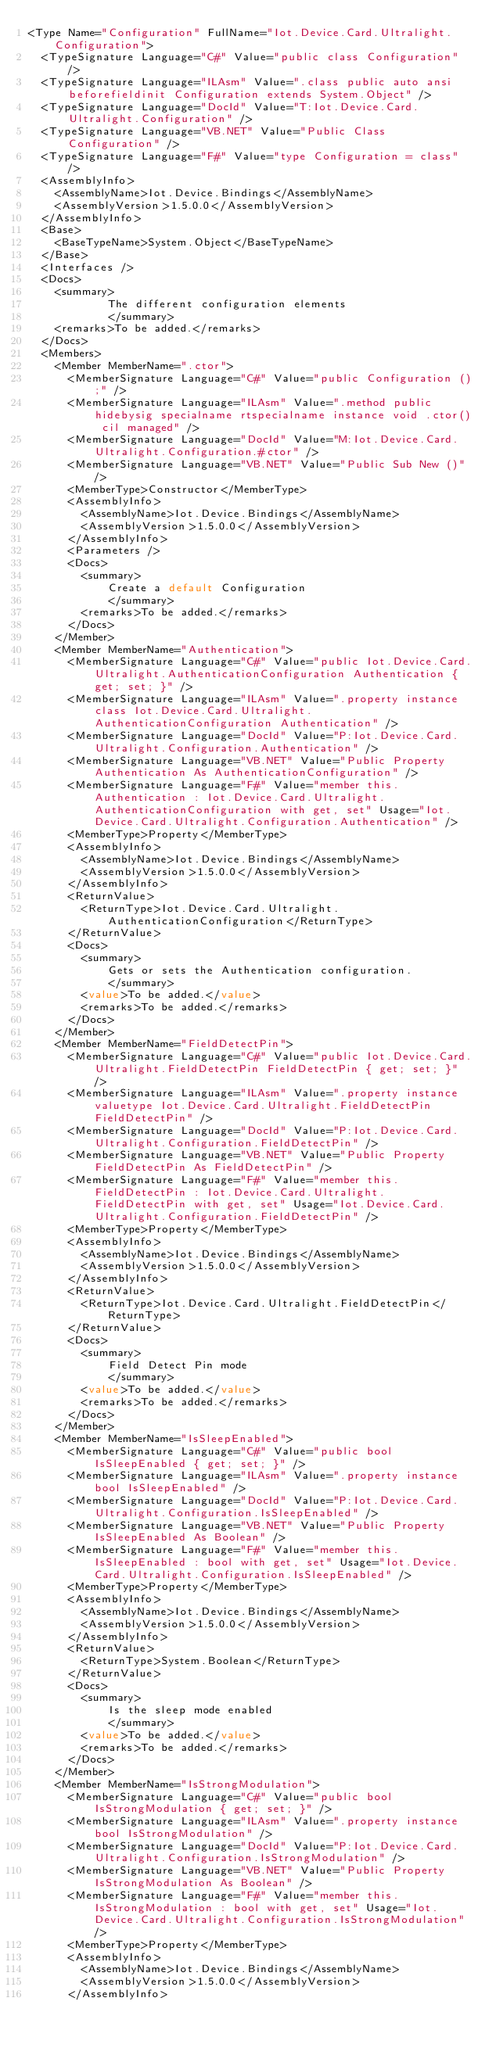Convert code to text. <code><loc_0><loc_0><loc_500><loc_500><_XML_><Type Name="Configuration" FullName="Iot.Device.Card.Ultralight.Configuration">
  <TypeSignature Language="C#" Value="public class Configuration" />
  <TypeSignature Language="ILAsm" Value=".class public auto ansi beforefieldinit Configuration extends System.Object" />
  <TypeSignature Language="DocId" Value="T:Iot.Device.Card.Ultralight.Configuration" />
  <TypeSignature Language="VB.NET" Value="Public Class Configuration" />
  <TypeSignature Language="F#" Value="type Configuration = class" />
  <AssemblyInfo>
    <AssemblyName>Iot.Device.Bindings</AssemblyName>
    <AssemblyVersion>1.5.0.0</AssemblyVersion>
  </AssemblyInfo>
  <Base>
    <BaseTypeName>System.Object</BaseTypeName>
  </Base>
  <Interfaces />
  <Docs>
    <summary>
            The different configuration elements
            </summary>
    <remarks>To be added.</remarks>
  </Docs>
  <Members>
    <Member MemberName=".ctor">
      <MemberSignature Language="C#" Value="public Configuration ();" />
      <MemberSignature Language="ILAsm" Value=".method public hidebysig specialname rtspecialname instance void .ctor() cil managed" />
      <MemberSignature Language="DocId" Value="M:Iot.Device.Card.Ultralight.Configuration.#ctor" />
      <MemberSignature Language="VB.NET" Value="Public Sub New ()" />
      <MemberType>Constructor</MemberType>
      <AssemblyInfo>
        <AssemblyName>Iot.Device.Bindings</AssemblyName>
        <AssemblyVersion>1.5.0.0</AssemblyVersion>
      </AssemblyInfo>
      <Parameters />
      <Docs>
        <summary>
            Create a default Configuration
            </summary>
        <remarks>To be added.</remarks>
      </Docs>
    </Member>
    <Member MemberName="Authentication">
      <MemberSignature Language="C#" Value="public Iot.Device.Card.Ultralight.AuthenticationConfiguration Authentication { get; set; }" />
      <MemberSignature Language="ILAsm" Value=".property instance class Iot.Device.Card.Ultralight.AuthenticationConfiguration Authentication" />
      <MemberSignature Language="DocId" Value="P:Iot.Device.Card.Ultralight.Configuration.Authentication" />
      <MemberSignature Language="VB.NET" Value="Public Property Authentication As AuthenticationConfiguration" />
      <MemberSignature Language="F#" Value="member this.Authentication : Iot.Device.Card.Ultralight.AuthenticationConfiguration with get, set" Usage="Iot.Device.Card.Ultralight.Configuration.Authentication" />
      <MemberType>Property</MemberType>
      <AssemblyInfo>
        <AssemblyName>Iot.Device.Bindings</AssemblyName>
        <AssemblyVersion>1.5.0.0</AssemblyVersion>
      </AssemblyInfo>
      <ReturnValue>
        <ReturnType>Iot.Device.Card.Ultralight.AuthenticationConfiguration</ReturnType>
      </ReturnValue>
      <Docs>
        <summary>
            Gets or sets the Authentication configuration.
            </summary>
        <value>To be added.</value>
        <remarks>To be added.</remarks>
      </Docs>
    </Member>
    <Member MemberName="FieldDetectPin">
      <MemberSignature Language="C#" Value="public Iot.Device.Card.Ultralight.FieldDetectPin FieldDetectPin { get; set; }" />
      <MemberSignature Language="ILAsm" Value=".property instance valuetype Iot.Device.Card.Ultralight.FieldDetectPin FieldDetectPin" />
      <MemberSignature Language="DocId" Value="P:Iot.Device.Card.Ultralight.Configuration.FieldDetectPin" />
      <MemberSignature Language="VB.NET" Value="Public Property FieldDetectPin As FieldDetectPin" />
      <MemberSignature Language="F#" Value="member this.FieldDetectPin : Iot.Device.Card.Ultralight.FieldDetectPin with get, set" Usage="Iot.Device.Card.Ultralight.Configuration.FieldDetectPin" />
      <MemberType>Property</MemberType>
      <AssemblyInfo>
        <AssemblyName>Iot.Device.Bindings</AssemblyName>
        <AssemblyVersion>1.5.0.0</AssemblyVersion>
      </AssemblyInfo>
      <ReturnValue>
        <ReturnType>Iot.Device.Card.Ultralight.FieldDetectPin</ReturnType>
      </ReturnValue>
      <Docs>
        <summary>
            Field Detect Pin mode
            </summary>
        <value>To be added.</value>
        <remarks>To be added.</remarks>
      </Docs>
    </Member>
    <Member MemberName="IsSleepEnabled">
      <MemberSignature Language="C#" Value="public bool IsSleepEnabled { get; set; }" />
      <MemberSignature Language="ILAsm" Value=".property instance bool IsSleepEnabled" />
      <MemberSignature Language="DocId" Value="P:Iot.Device.Card.Ultralight.Configuration.IsSleepEnabled" />
      <MemberSignature Language="VB.NET" Value="Public Property IsSleepEnabled As Boolean" />
      <MemberSignature Language="F#" Value="member this.IsSleepEnabled : bool with get, set" Usage="Iot.Device.Card.Ultralight.Configuration.IsSleepEnabled" />
      <MemberType>Property</MemberType>
      <AssemblyInfo>
        <AssemblyName>Iot.Device.Bindings</AssemblyName>
        <AssemblyVersion>1.5.0.0</AssemblyVersion>
      </AssemblyInfo>
      <ReturnValue>
        <ReturnType>System.Boolean</ReturnType>
      </ReturnValue>
      <Docs>
        <summary>
            Is the sleep mode enabled
            </summary>
        <value>To be added.</value>
        <remarks>To be added.</remarks>
      </Docs>
    </Member>
    <Member MemberName="IsStrongModulation">
      <MemberSignature Language="C#" Value="public bool IsStrongModulation { get; set; }" />
      <MemberSignature Language="ILAsm" Value=".property instance bool IsStrongModulation" />
      <MemberSignature Language="DocId" Value="P:Iot.Device.Card.Ultralight.Configuration.IsStrongModulation" />
      <MemberSignature Language="VB.NET" Value="Public Property IsStrongModulation As Boolean" />
      <MemberSignature Language="F#" Value="member this.IsStrongModulation : bool with get, set" Usage="Iot.Device.Card.Ultralight.Configuration.IsStrongModulation" />
      <MemberType>Property</MemberType>
      <AssemblyInfo>
        <AssemblyName>Iot.Device.Bindings</AssemblyName>
        <AssemblyVersion>1.5.0.0</AssemblyVersion>
      </AssemblyInfo></code> 